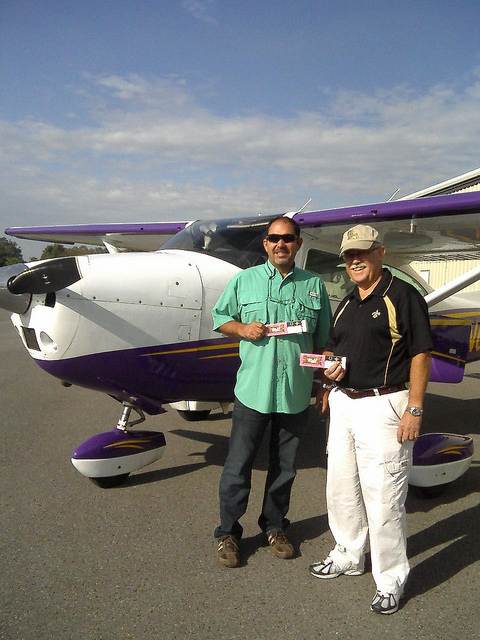How many people are in the photo? 2 